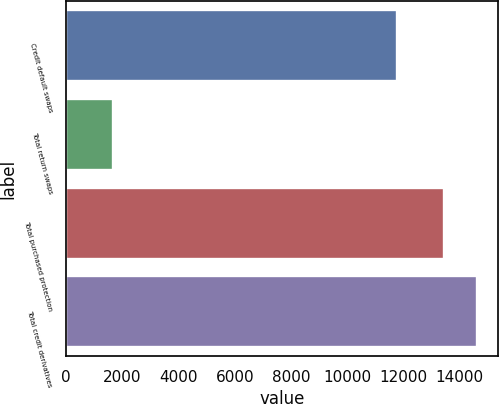<chart> <loc_0><loc_0><loc_500><loc_500><bar_chart><fcel>Credit default swaps<fcel>Total return swaps<fcel>Total purchased protection<fcel>Total credit derivatives<nl><fcel>11772<fcel>1678<fcel>13450<fcel>14627.2<nl></chart> 